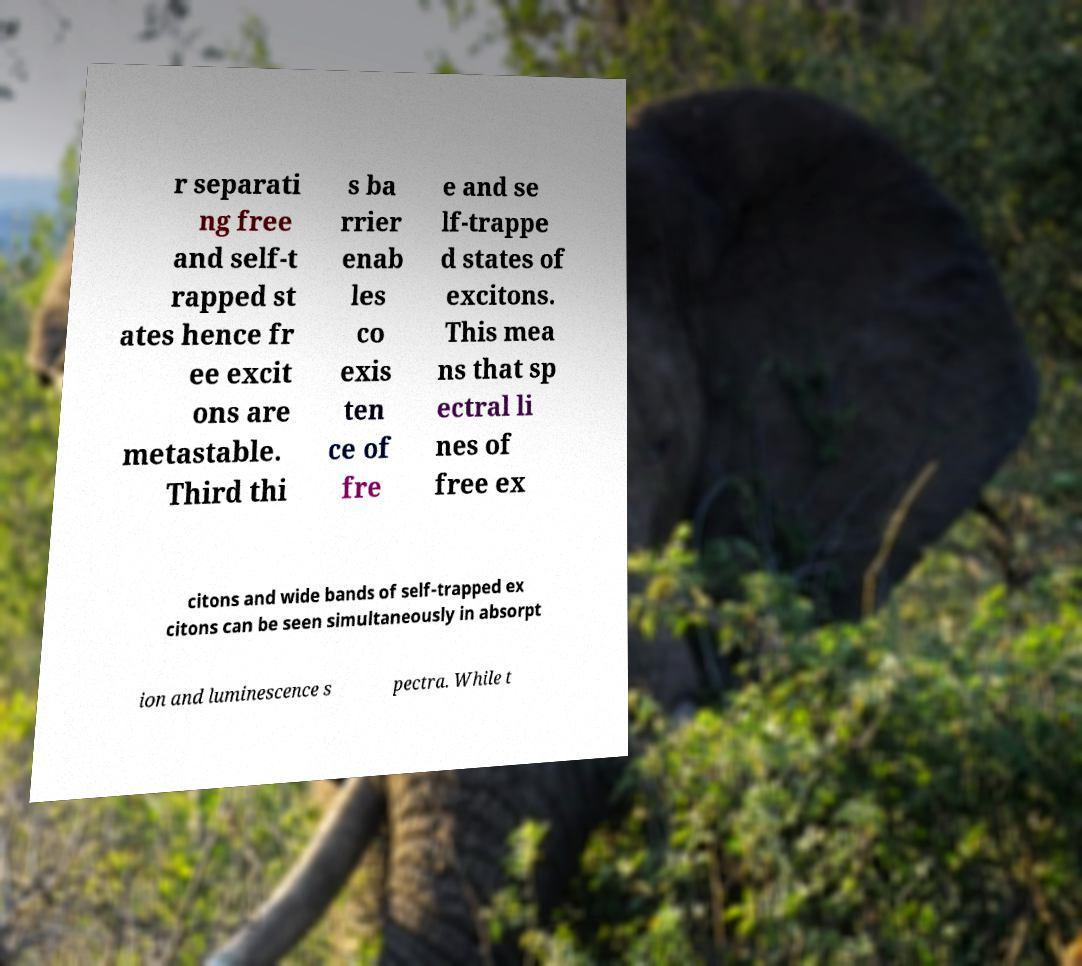Can you read and provide the text displayed in the image?This photo seems to have some interesting text. Can you extract and type it out for me? r separati ng free and self-t rapped st ates hence fr ee excit ons are metastable. Third thi s ba rrier enab les co exis ten ce of fre e and se lf-trappe d states of excitons. This mea ns that sp ectral li nes of free ex citons and wide bands of self-trapped ex citons can be seen simultaneously in absorpt ion and luminescence s pectra. While t 